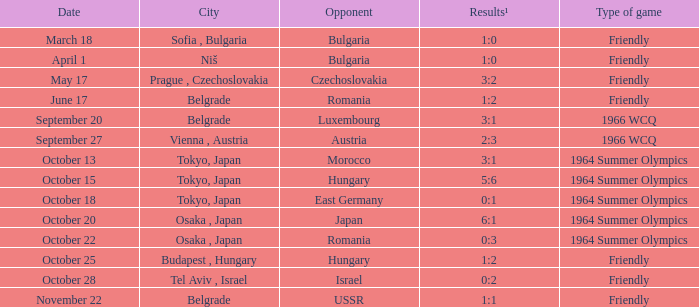Wjich city had a date of october 13? Tokyo, Japan. I'm looking to parse the entire table for insights. Could you assist me with that? {'header': ['Date', 'City', 'Opponent', 'Results¹', 'Type of game'], 'rows': [['March 18', 'Sofia , Bulgaria', 'Bulgaria', '1:0', 'Friendly'], ['April 1', 'Niš', 'Bulgaria', '1:0', 'Friendly'], ['May 17', 'Prague , Czechoslovakia', 'Czechoslovakia', '3:2', 'Friendly'], ['June 17', 'Belgrade', 'Romania', '1:2', 'Friendly'], ['September 20', 'Belgrade', 'Luxembourg', '3:1', '1966 WCQ'], ['September 27', 'Vienna , Austria', 'Austria', '2:3', '1966 WCQ'], ['October 13', 'Tokyo, Japan', 'Morocco', '3:1', '1964 Summer Olympics'], ['October 15', 'Tokyo, Japan', 'Hungary', '5:6', '1964 Summer Olympics'], ['October 18', 'Tokyo, Japan', 'East Germany', '0:1', '1964 Summer Olympics'], ['October 20', 'Osaka , Japan', 'Japan', '6:1', '1964 Summer Olympics'], ['October 22', 'Osaka , Japan', 'Romania', '0:3', '1964 Summer Olympics'], ['October 25', 'Budapest , Hungary', 'Hungary', '1:2', 'Friendly'], ['October 28', 'Tel Aviv , Israel', 'Israel', '0:2', 'Friendly'], ['November 22', 'Belgrade', 'USSR', '1:1', 'Friendly']]} 